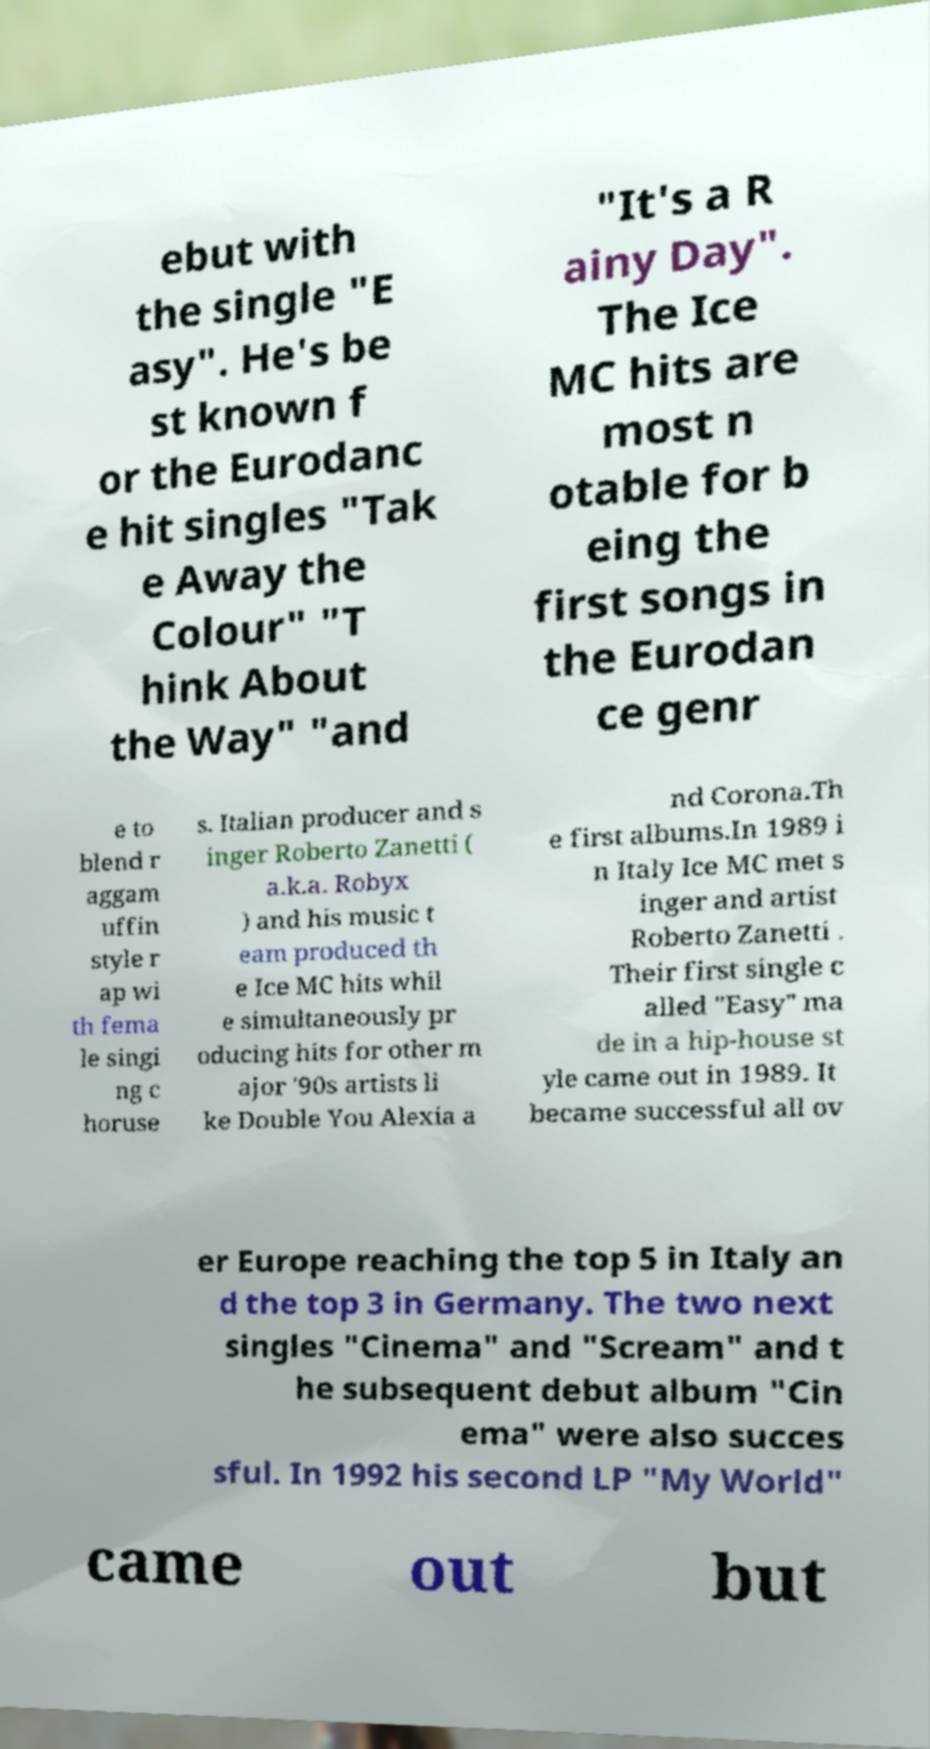I need the written content from this picture converted into text. Can you do that? ebut with the single "E asy". He's be st known f or the Eurodanc e hit singles "Tak e Away the Colour" "T hink About the Way" "and "It's a R ainy Day". The Ice MC hits are most n otable for b eing the first songs in the Eurodan ce genr e to blend r aggam uffin style r ap wi th fema le singi ng c horuse s. Italian producer and s inger Roberto Zanetti ( a.k.a. Robyx ) and his music t eam produced th e Ice MC hits whil e simultaneously pr oducing hits for other m ajor '90s artists li ke Double You Alexia a nd Corona.Th e first albums.In 1989 i n Italy Ice MC met s inger and artist Roberto Zanetti . Their first single c alled "Easy" ma de in a hip-house st yle came out in 1989. It became successful all ov er Europe reaching the top 5 in Italy an d the top 3 in Germany. The two next singles "Cinema" and "Scream" and t he subsequent debut album "Cin ema" were also succes sful. In 1992 his second LP "My World" came out but 